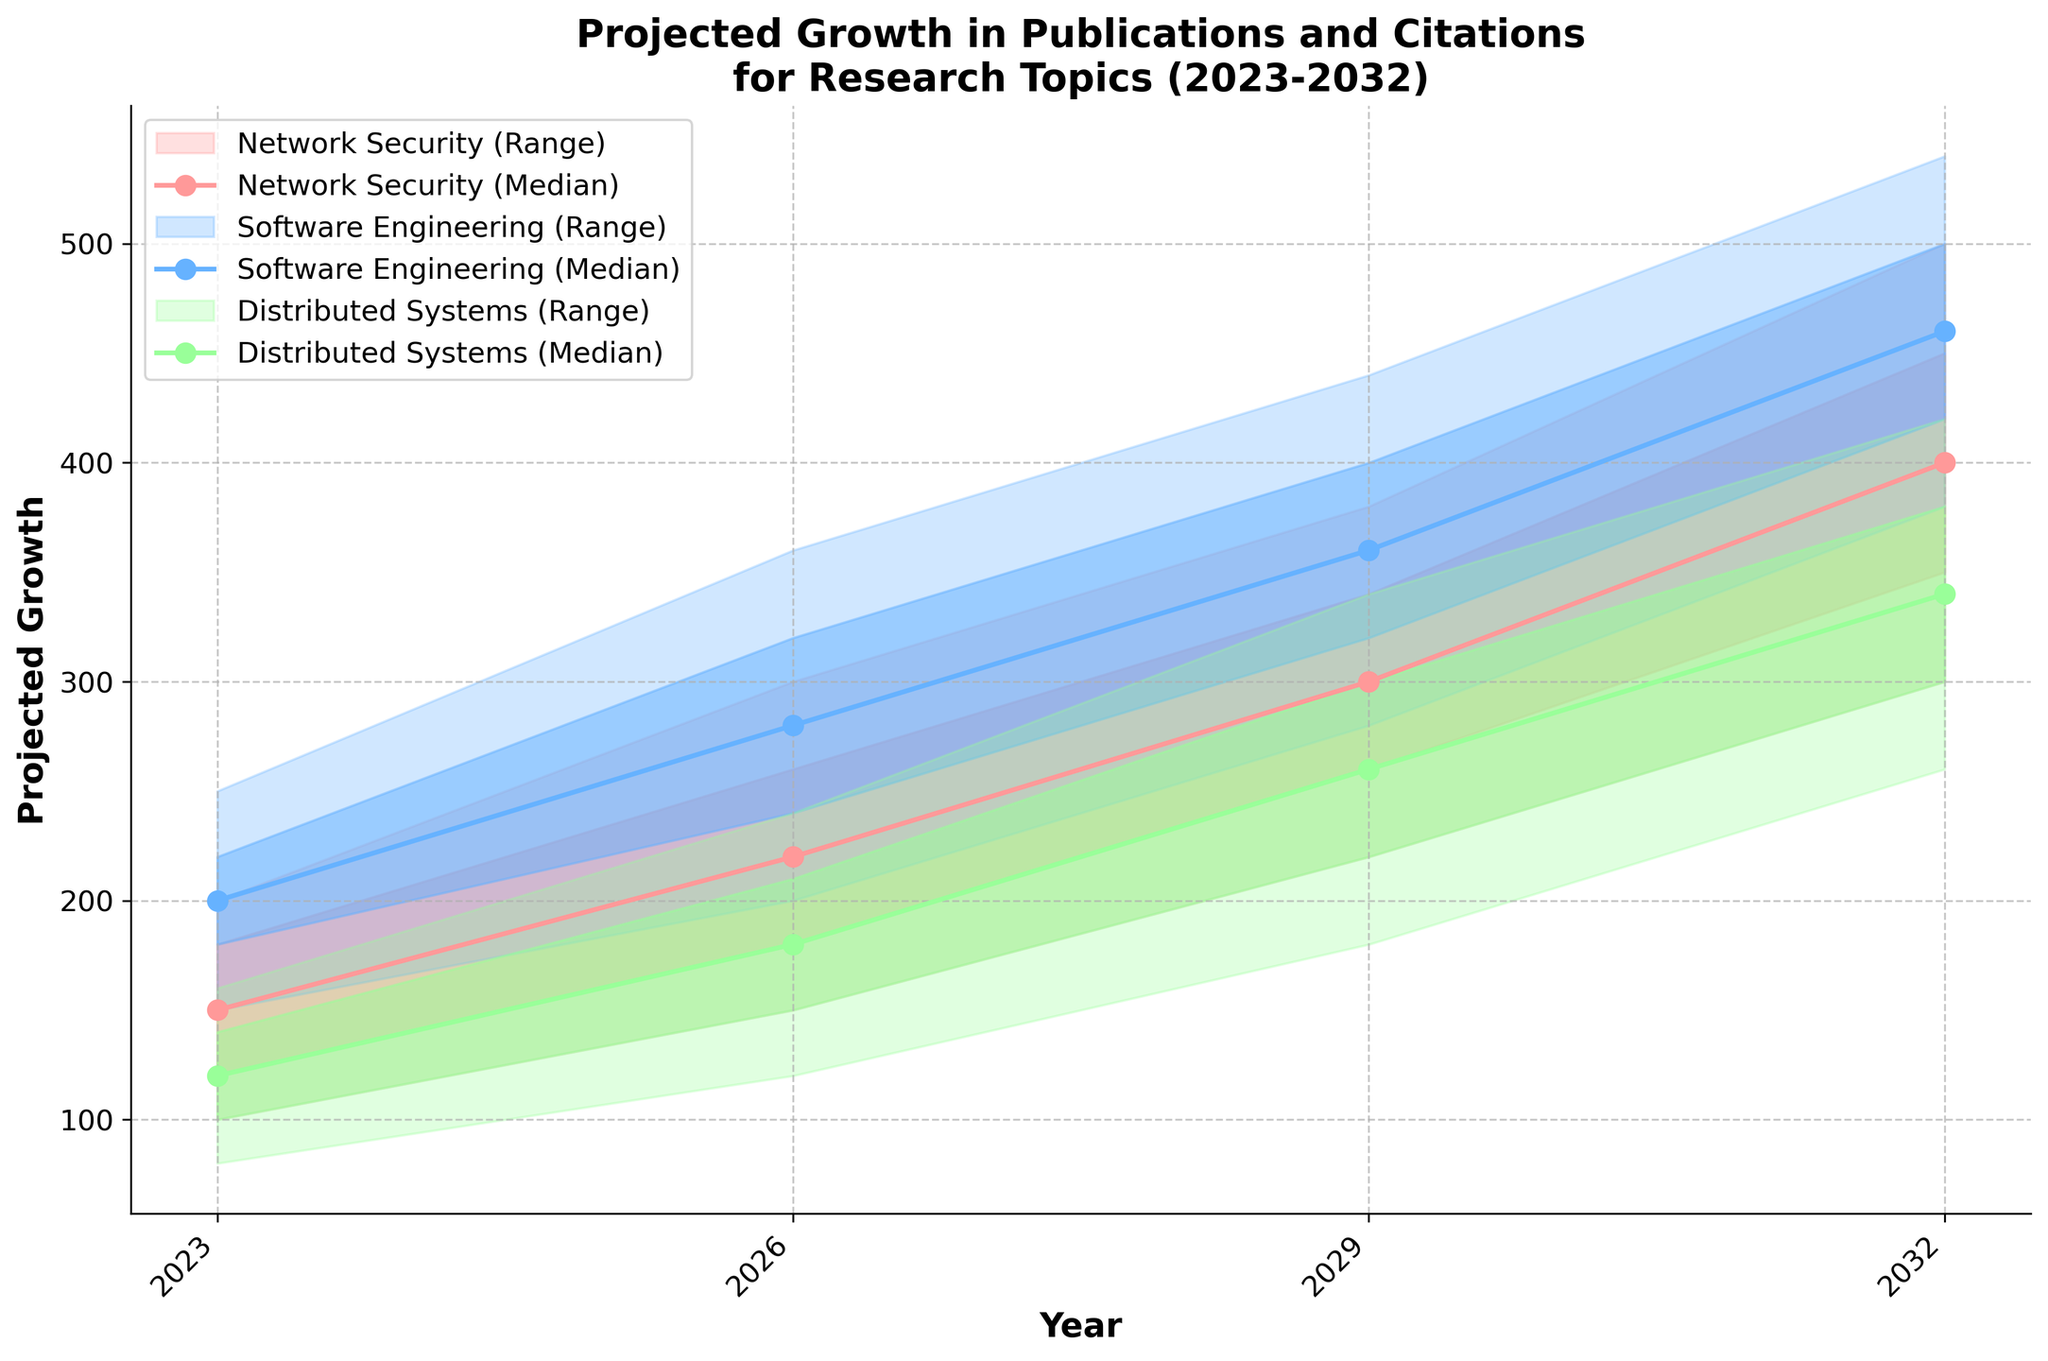What does the x-axis represent in the chart? The x-axis in the chart is labeled "Year," which represents the time frame from 2023 to 2032.
Answer: Year What are the upper and lower bounds for Network Security in 2026? For Network Security in 2026, the lower bound is 150 and the upper bound is 300.
Answer: 150, 300 Which subfield has the highest median projected growth in 2032? Read the median projections for all subfields in 2032: Network Security (400), Software Engineering (460), Distributed Systems (340). Compare the values. Software Engineering has the highest median projected growth of 460.
Answer: Software Engineering By how much does the median for Distributed Systems grow from 2023 to 2029? Find the median value for Distributed Systems in 2023 (120) and in 2029 (260). Calculate the difference: 260 - 120 = 140.
Answer: 140 How does the range of projections for Software Engineering change from 2023 to 2032? The range is calculated as the difference between the upper bound and the lower bound. For 2023, the range is 250 - 150 = 100. For 2032, the range is 540 - 380 = 160. Compare the range for the two years: 160 - 100 = 60. The range increases by 60.
Answer: The range increases by 60 Which subfield shows the largest increase in the median projection from 2026 to 2032? Calculate the increase in the median projection for each subfield between 2026 and 2032. Network Security: 400 - 220 = 180. Software Engineering: 460 - 280 = 180. Distributed Systems: 340 - 180 = 160. Network Security and Software Engineering both show the largest increase of 180.
Answer: Network Security and Software Engineering What is the median projected growth for Software Engineering in 2029? Read the median value for Software Engineering in 2029, which is directly indicated in the chart as 360.
Answer: 360 Which subfield has the smallest lower bound in 2023? Compare the lower bounds for all subfields in 2023. Network Security (100), Software Engineering (150), Distributed Systems (80). Distributed Systems has the smallest lower bound.
Answer: Distributed Systems Between 2023 and 2029, which subfield shows the most consistent upward trend in its median projections? To determine consistency, observe the median projection values for each subfield between 2023 and 2029. All subfields show a consistent upward trend, but Software Engineering has the largest and steadily increasing median values: 200 (2023), 280 (2026), 360 (2029).
Answer: Software Engineering 